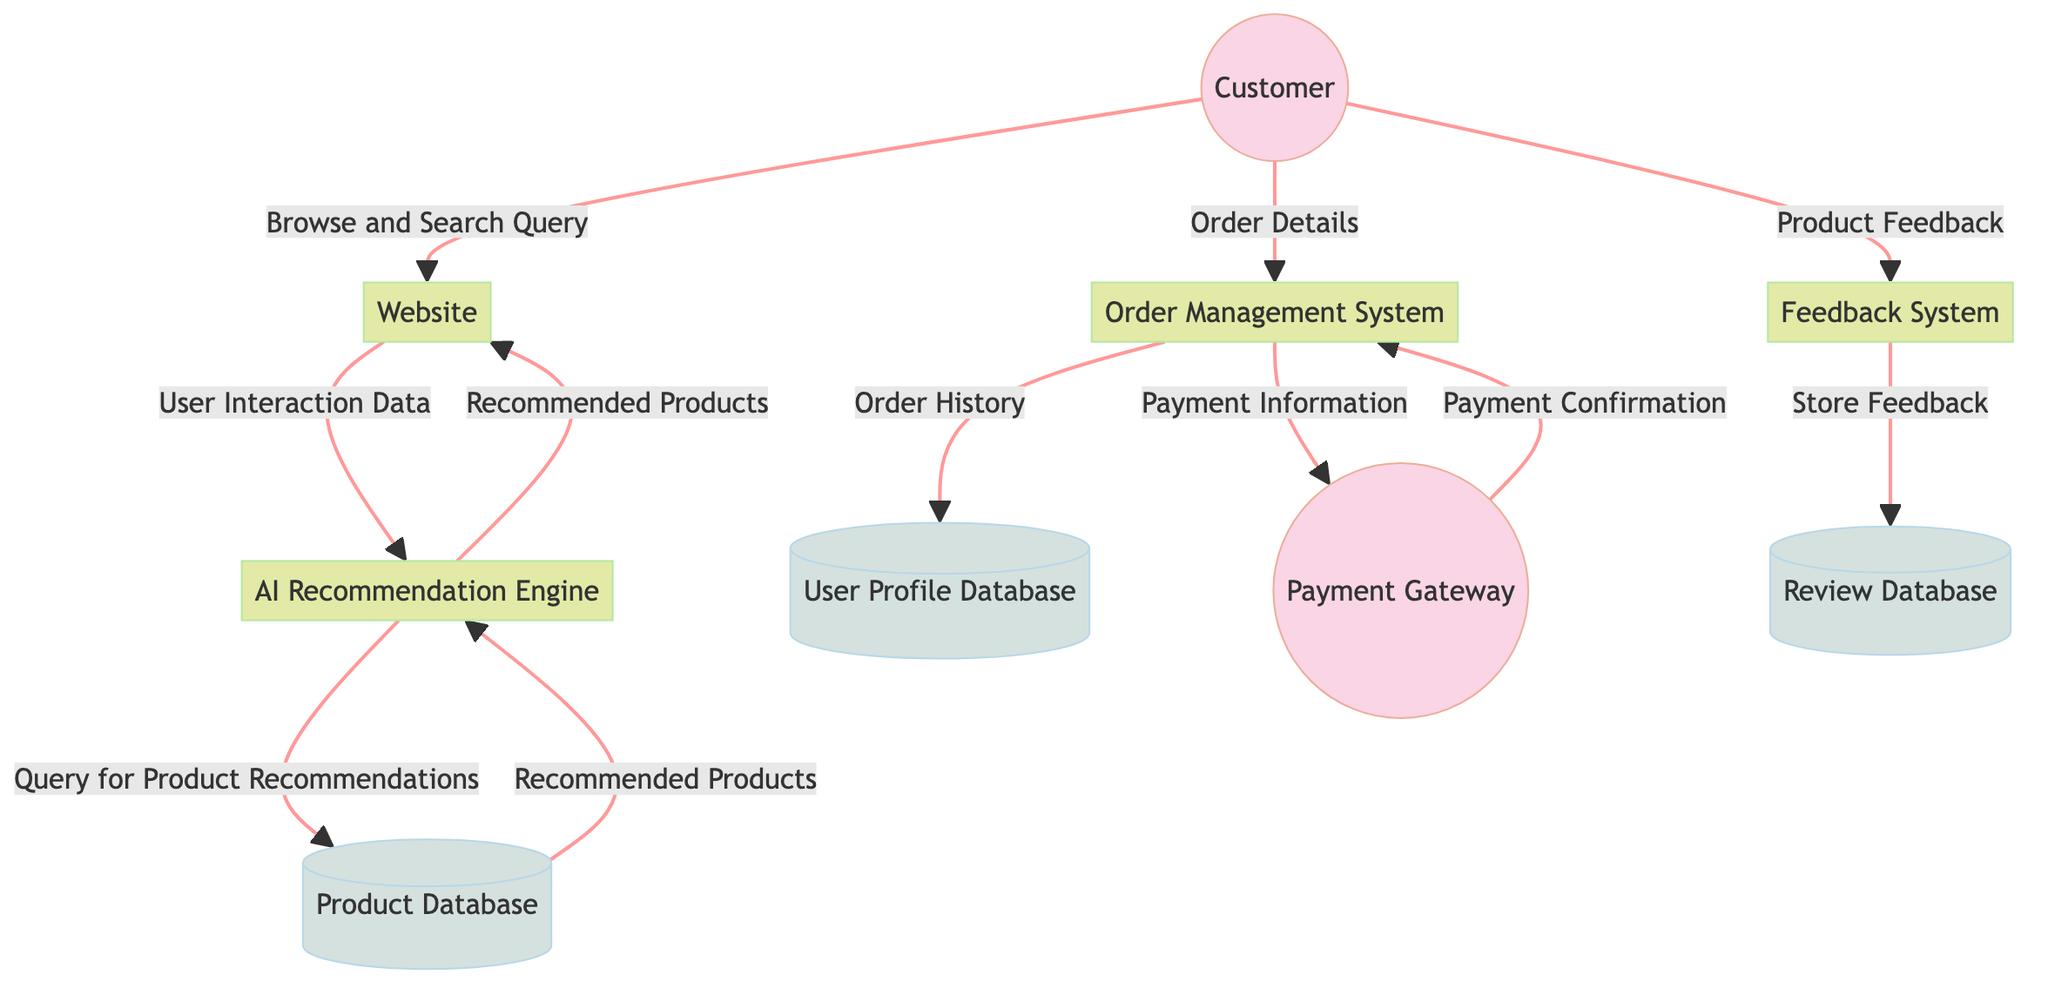What's the initial action taken by the Customer in the flow? The diagram shows that the Customer initiates the process by sending a "Browse and Search Query" to the Website. This query marks the starting point of the customer interaction with the AI product.
Answer: Browse and Search Query How many processes are there in the diagram? The diagram includes a total of five processes: Website, AI Recommendation Engine, Order Management System, Payment Gateway, and Feedback System. By counting each unique process node, we arrive at the total.
Answer: Five What data does the Website send to the AI Recommendation Engine? The data flow from the Website to the AI Recommendation Engine consists of "User Interaction Data," which is essential for the recommendation system to function effectively.
Answer: User Interaction Data What does the AI Recommendation Engine retrieve from the Product Database? The diagram indicates that the AI Recommendation Engine sends a query to the Product Database for "Product Recommendations," which it uses to provide customized suggestions to the user.
Answer: Query for Product Recommendations What is the final action taken by the Feedback System? According to the diagram, the Feedback System's final action is to "Store Feedback" in the Review Database, which is critical for capturing user impressions and reviews.
Answer: Store Feedback How does the Order Management System interact with the Payment Gateway? The Order Management System sends "Payment Information" to the Payment Gateway to facilitate the transaction process, and in return, it receives "Payment Confirmation" from the Payment Gateway once the payment is processed. This shows a bidirectional interaction between these two entities.
Answer: Payment Information What role does the User Profile Database play in the overall flow? The User Profile Database is where the Order Management System sends the "Order History" after processing an order. This interaction helps maintain a record of customer transactions for future reference.
Answer: Order History Which entity provides feedback on products? The Customer is the entity that provides feedback through the "Product Feedback" data flow directed to the Feedback System. This highlights the customer’s involvement in giving feedback regarding their purchases.
Answer: Product Feedback What type of database is the Review Database classified as? The Review Database is classified as a Data Store in the diagram, meaning it is used to hold and store information regarding customer reviews and feedback.
Answer: Data Store 